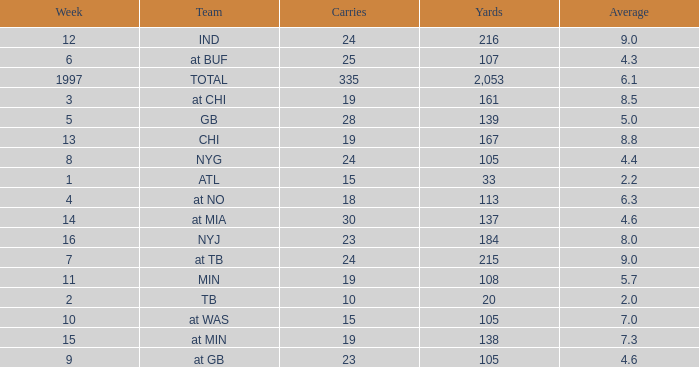Which Team has 19 Carries, and a Week larger than 13? At min. 